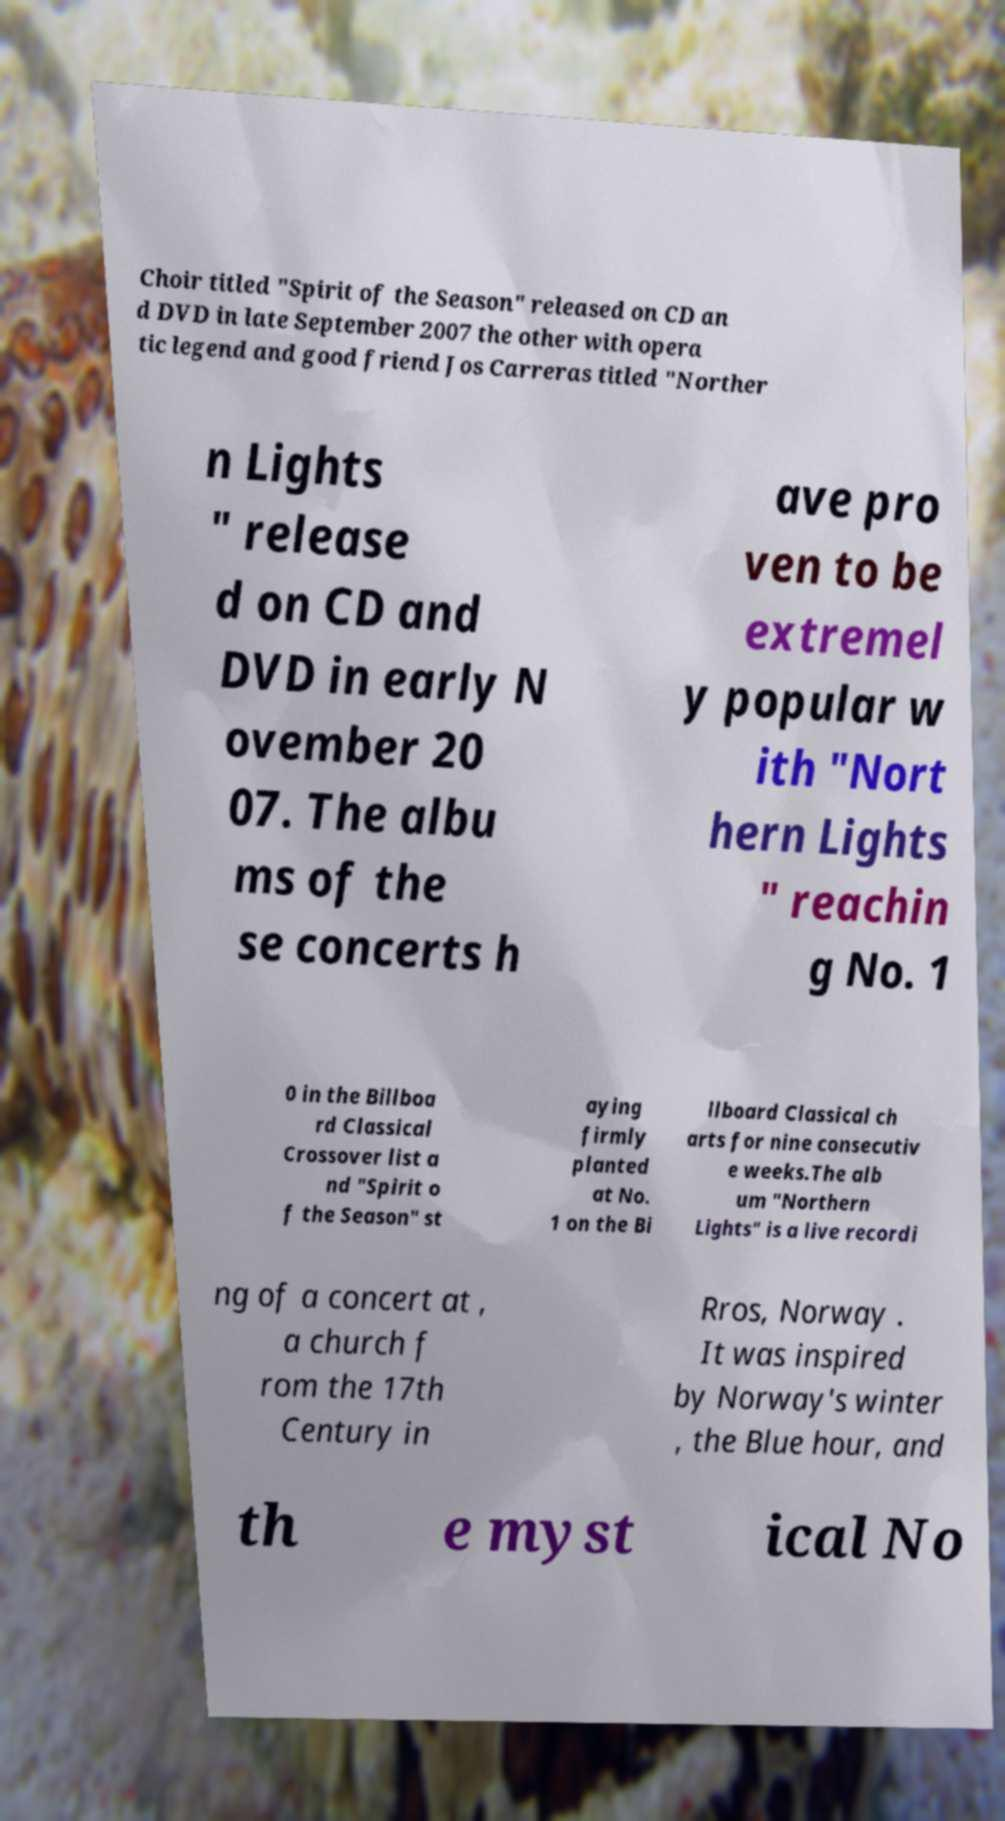For documentation purposes, I need the text within this image transcribed. Could you provide that? Choir titled "Spirit of the Season" released on CD an d DVD in late September 2007 the other with opera tic legend and good friend Jos Carreras titled "Norther n Lights " release d on CD and DVD in early N ovember 20 07. The albu ms of the se concerts h ave pro ven to be extremel y popular w ith "Nort hern Lights " reachin g No. 1 0 in the Billboa rd Classical Crossover list a nd "Spirit o f the Season" st aying firmly planted at No. 1 on the Bi llboard Classical ch arts for nine consecutiv e weeks.The alb um "Northern Lights" is a live recordi ng of a concert at , a church f rom the 17th Century in Rros, Norway . It was inspired by Norway's winter , the Blue hour, and th e myst ical No 